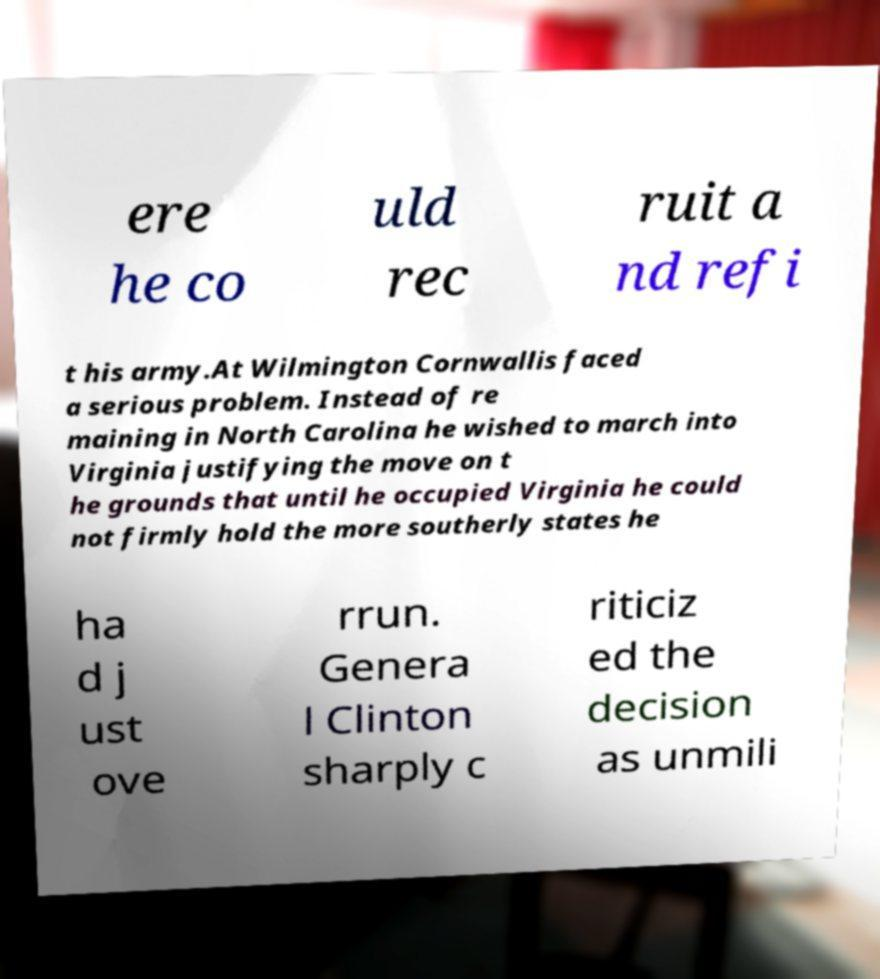There's text embedded in this image that I need extracted. Can you transcribe it verbatim? ere he co uld rec ruit a nd refi t his army.At Wilmington Cornwallis faced a serious problem. Instead of re maining in North Carolina he wished to march into Virginia justifying the move on t he grounds that until he occupied Virginia he could not firmly hold the more southerly states he ha d j ust ove rrun. Genera l Clinton sharply c riticiz ed the decision as unmili 